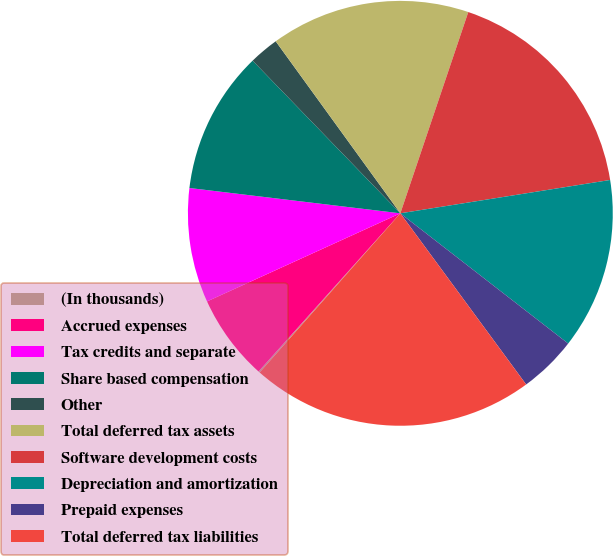<chart> <loc_0><loc_0><loc_500><loc_500><pie_chart><fcel>(In thousands)<fcel>Accrued expenses<fcel>Tax credits and separate<fcel>Share based compensation<fcel>Other<fcel>Total deferred tax assets<fcel>Software development costs<fcel>Depreciation and amortization<fcel>Prepaid expenses<fcel>Total deferred tax liabilities<nl><fcel>0.11%<fcel>6.56%<fcel>8.71%<fcel>10.86%<fcel>2.26%<fcel>15.16%<fcel>17.31%<fcel>13.01%<fcel>4.41%<fcel>21.61%<nl></chart> 